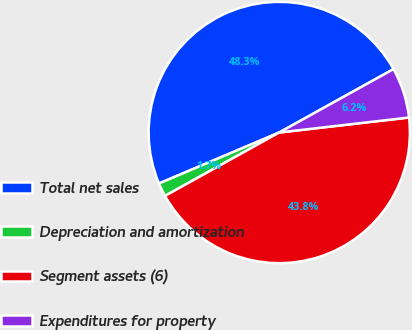Convert chart to OTSL. <chart><loc_0><loc_0><loc_500><loc_500><pie_chart><fcel>Total net sales<fcel>Depreciation and amortization<fcel>Segment assets (6)<fcel>Expenditures for property<nl><fcel>48.32%<fcel>1.68%<fcel>43.77%<fcel>6.23%<nl></chart> 